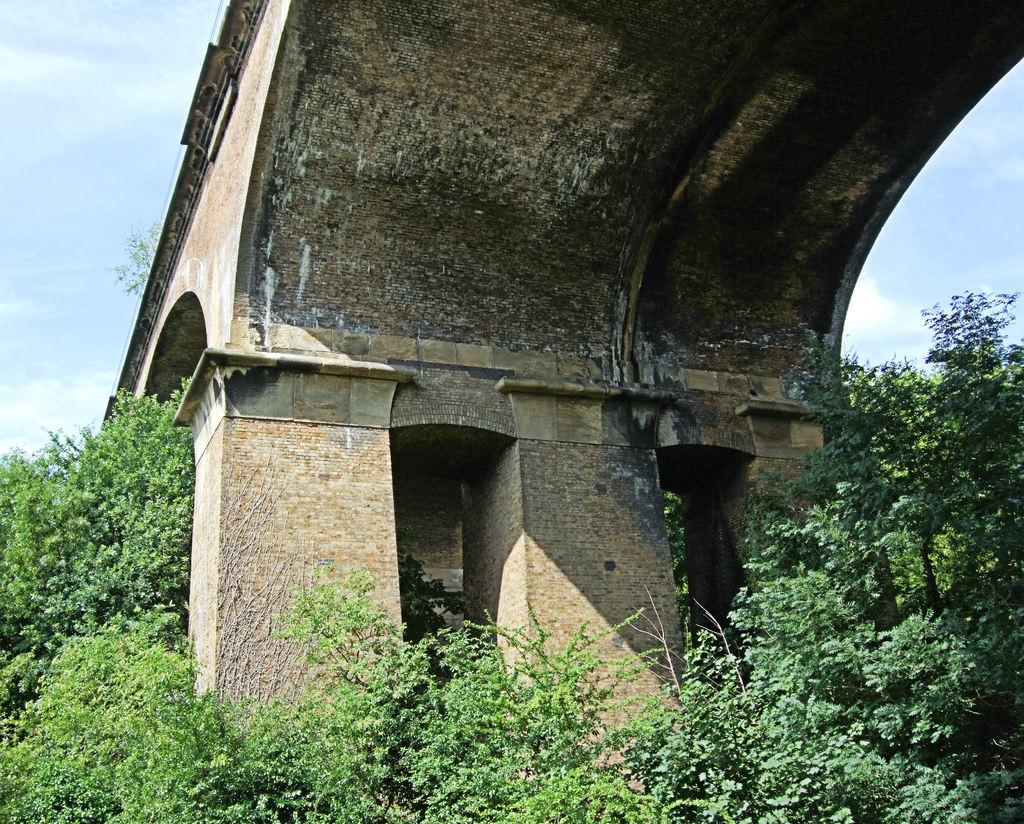What structure can be seen in the image? There is a bridge in the image. What type of vegetation is present in the image? There are trees in the image. What can be seen in the sky in the image? There are clouds visible in the sky in the image. How many flowers are visible on the bridge in the image? There are no flowers visible on the bridge in the image. What is the chance of rain in the image? The image does not provide any information about the chance of rain. 